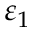Convert formula to latex. <formula><loc_0><loc_0><loc_500><loc_500>\varepsilon _ { 1 }</formula> 